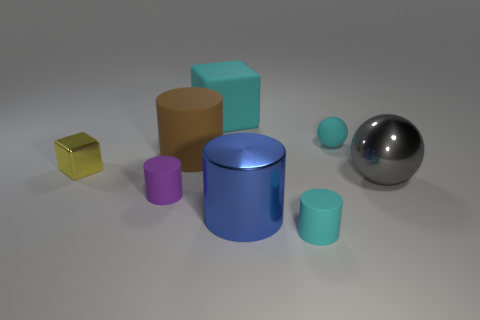Subtract all large metallic cylinders. How many cylinders are left? 3 Add 2 big blue cylinders. How many objects exist? 10 Subtract all cyan cylinders. How many cylinders are left? 3 Subtract 1 cylinders. How many cylinders are left? 3 Subtract all balls. How many objects are left? 6 Subtract all red cubes. Subtract all yellow balls. How many cubes are left? 2 Subtract all large yellow shiny balls. Subtract all cyan matte objects. How many objects are left? 5 Add 4 matte cubes. How many matte cubes are left? 5 Add 4 large purple metal spheres. How many large purple metal spheres exist? 4 Subtract 0 gray cylinders. How many objects are left? 8 